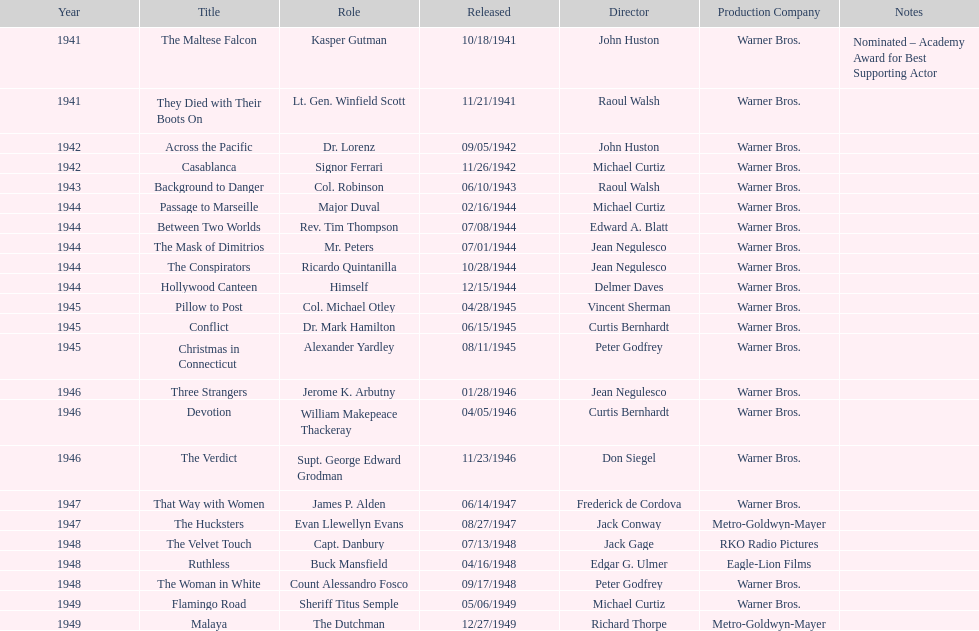How many movies has he been from 1941-1949. 23. 